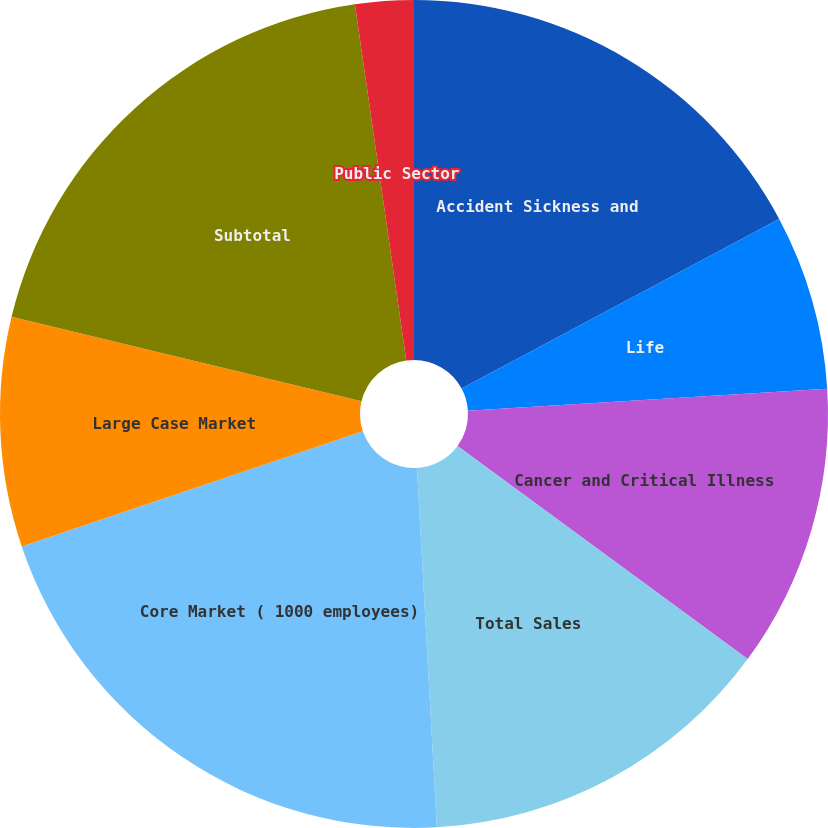Convert chart to OTSL. <chart><loc_0><loc_0><loc_500><loc_500><pie_chart><fcel>Accident Sickness and<fcel>Life<fcel>Cancer and Critical Illness<fcel>Total Sales<fcel>Core Market ( 1000 employees)<fcel>Large Case Market<fcel>Subtotal<fcel>Public Sector<nl><fcel>17.19%<fcel>6.84%<fcel>11.05%<fcel>14.04%<fcel>20.7%<fcel>8.95%<fcel>18.95%<fcel>2.28%<nl></chart> 